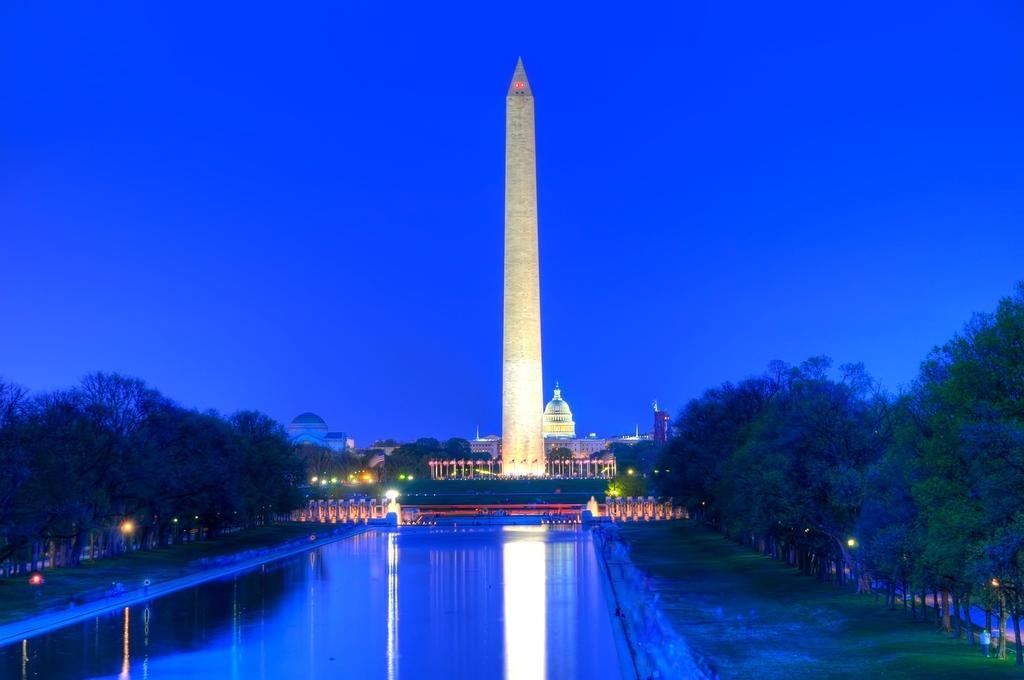Describe this image in one or two sentences. In this image I can see the water, background I can see few trees, lights and I can also see the tower, few buildings and the sky is in blue color. 